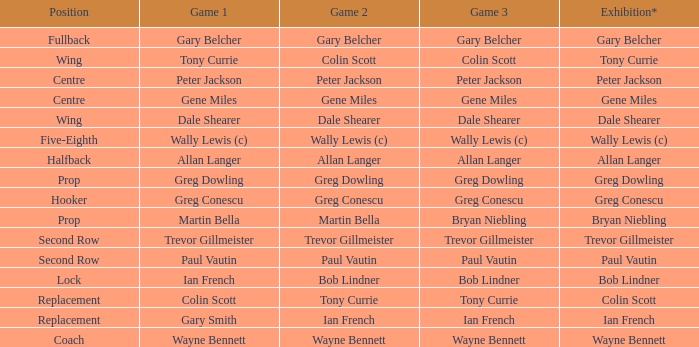What exhibition has greg conescu as game 1? Greg Conescu. 